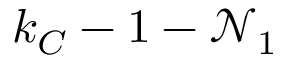Convert formula to latex. <formula><loc_0><loc_0><loc_500><loc_500>k _ { C } - 1 - \mathcal { N } _ { 1 }</formula> 